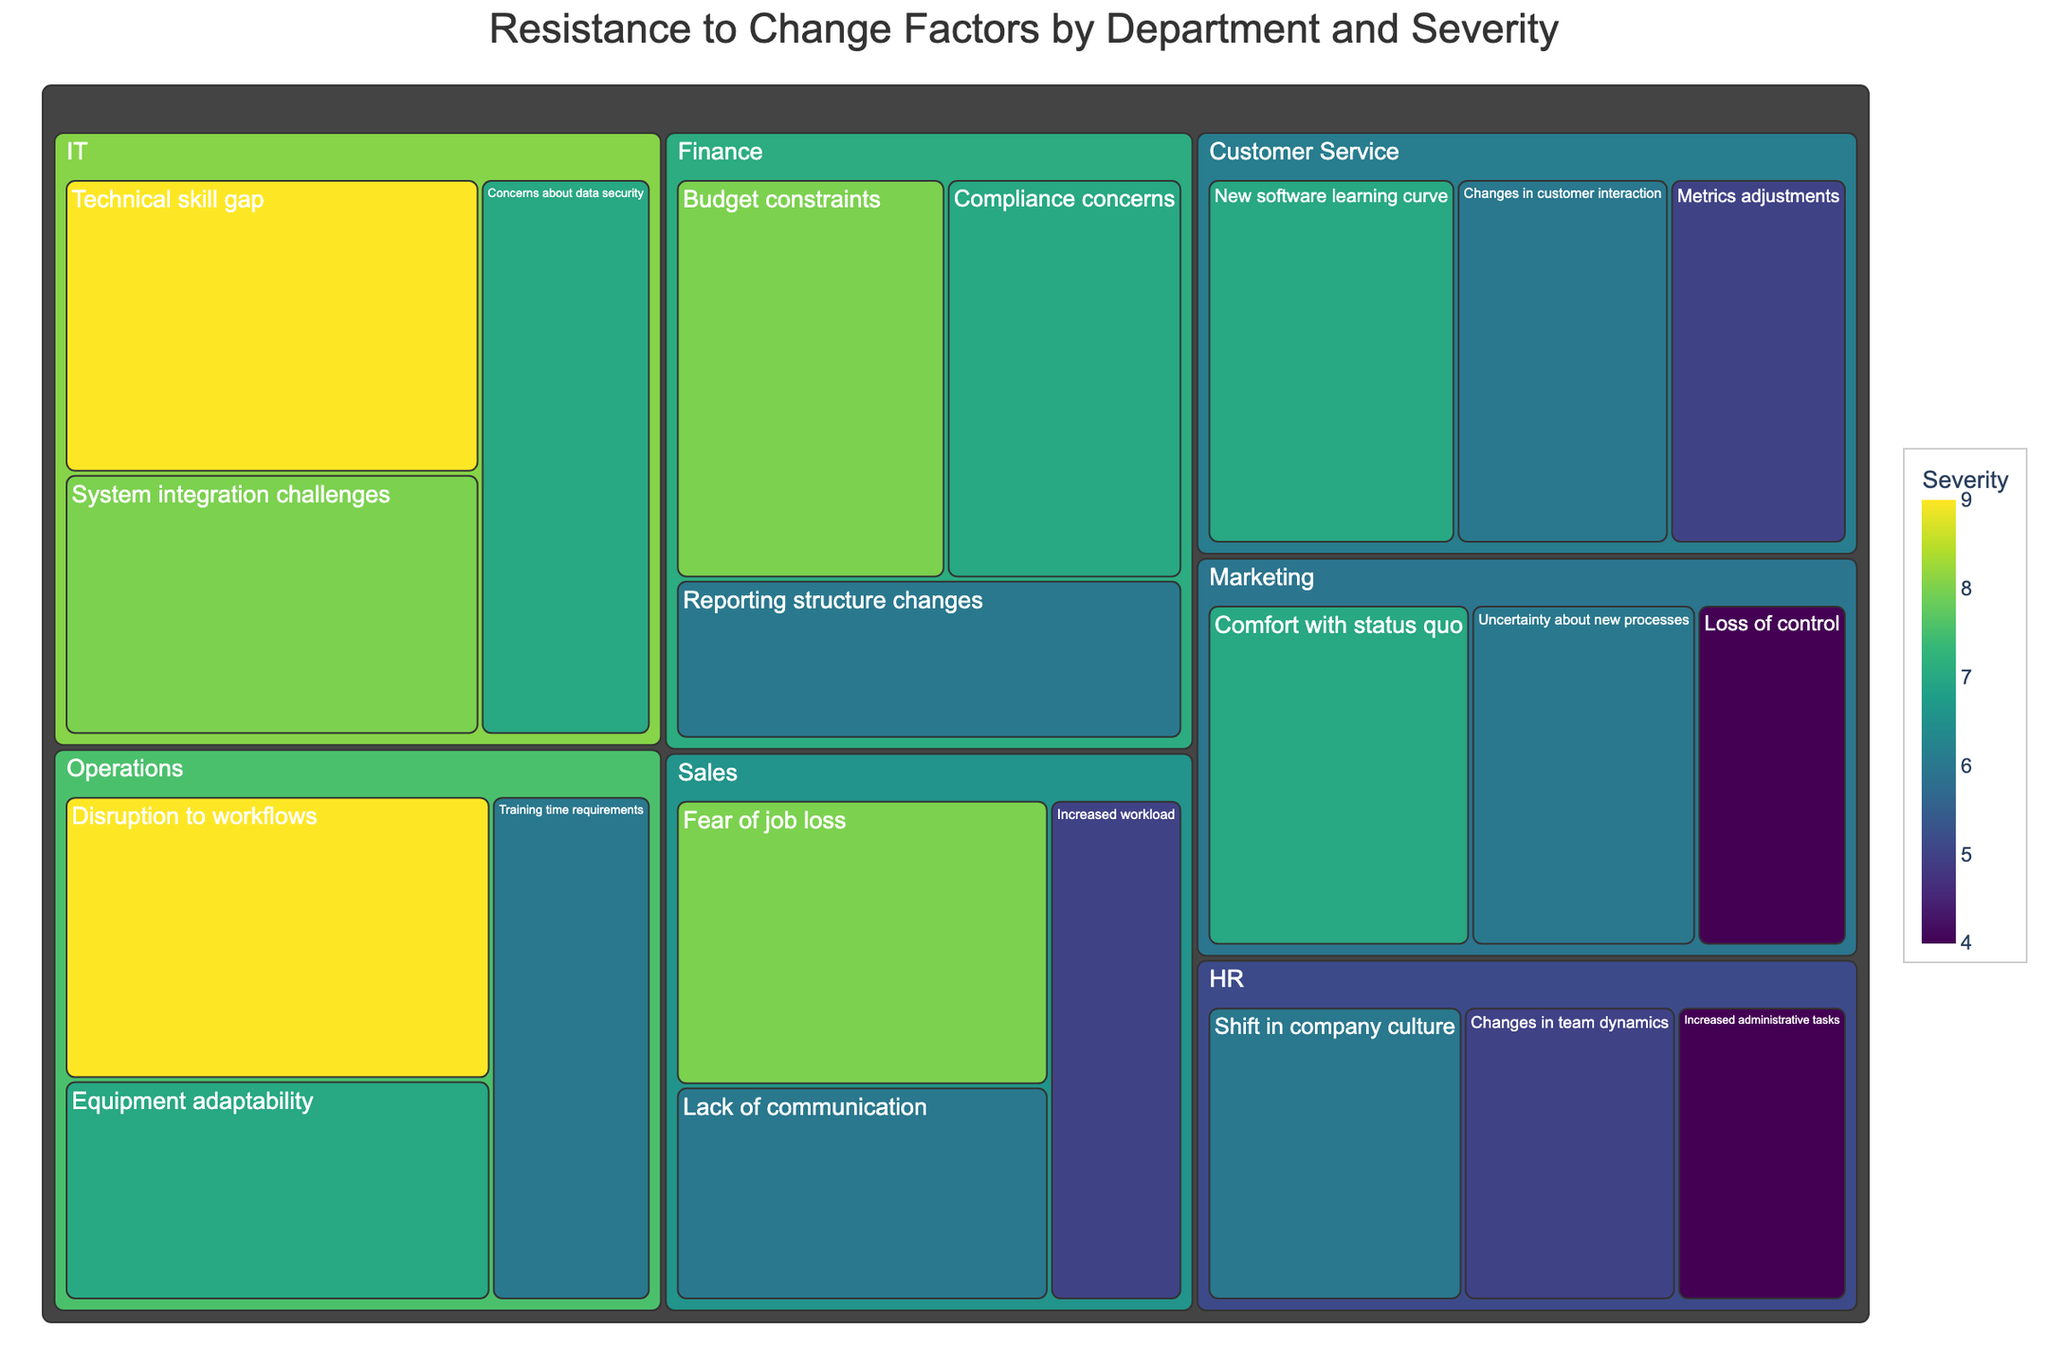What is the most severe resistance factor in the Sales department? In the Sales department, the factor with the highest severity score is 'Fear of job loss', which has a severity of 8.
Answer: Fear of job loss How many factors are listed for the HR department? The HR department lists 'Shift in company culture,' 'Changes in team dynamics,' and 'Increased administrative tasks' as resistance factors, making up a total of three factors.
Answer: 3 Which department has 'Concerns about data security' as a resistance factor? The 'Concerns about data security' factor shows up under the IT department in the treemap.
Answer: IT Which resistance factor has a severity of 9 in the Operations department? The factor 'Disruption to workflows' in the Operations department has the highest severity of 9.
Answer: Disruption to workflows Compare the severity of 'Budget constraints' in Finance to 'Technical skill gap' in IT. Which is higher? In the Finance department, 'Budget constraints' has a severity of 8, whereas 'Technical skill gap' in IT has a severity of 9. Therefore, the 'Technical skill gap' is higher.
Answer: Technical skill gap What is the average severity of resistance factors in the Marketing department? The Marketing department has 'Comfort with status quo' (7), 'Uncertainty about new processes' (6), and 'Loss of control' (4). The average severity is calculated by summing these values (7 + 6 + 4 = 17) and dividing by 3, which equals 5.67.
Answer: 5.67 Which departments have at least one resistance factor with a severity of 6? Departments with at least one resistance factor having a severity of 6 are Sales, Marketing, HR, Finance, Operations, and Customer Service.
Answer: Sales, Marketing, HR, Finance, Operations, Customer Service What is the most common severity score across all departments? The most common severity score among all listed factors is 6. This score appears multiple times across different departments.
Answer: 6 In the IT department, what are the resistance factors with severity scores higher than 7? Factors in the IT department with severity scores higher than 7 are 'Technical skill gap' (9) and 'System integration challenges' (8).
Answer: Technical skill gap, System integration challenges 